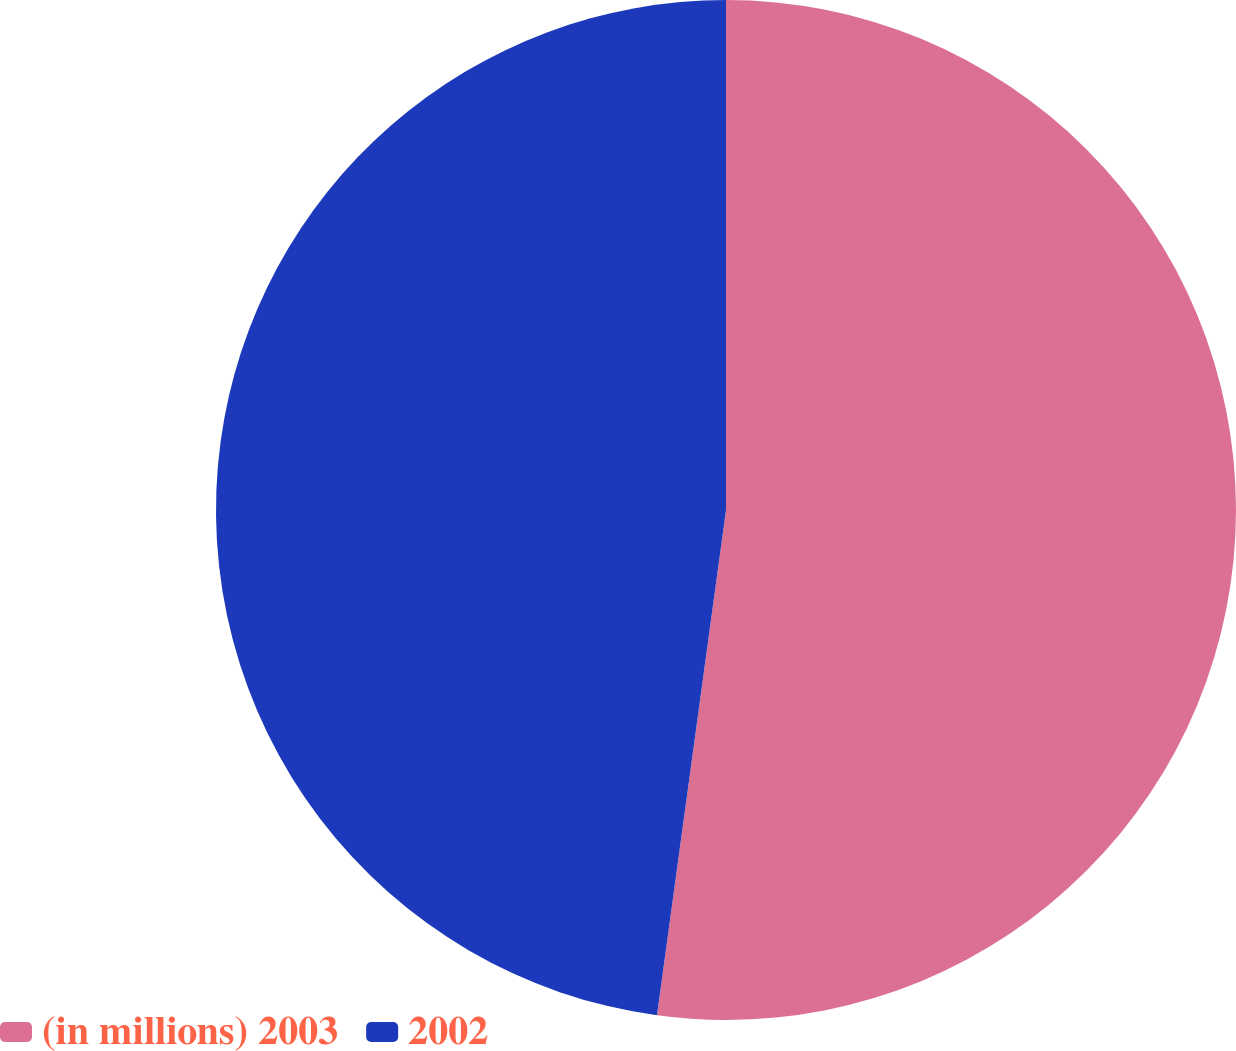Convert chart to OTSL. <chart><loc_0><loc_0><loc_500><loc_500><pie_chart><fcel>(in millions) 2003<fcel>2002<nl><fcel>52.16%<fcel>47.84%<nl></chart> 